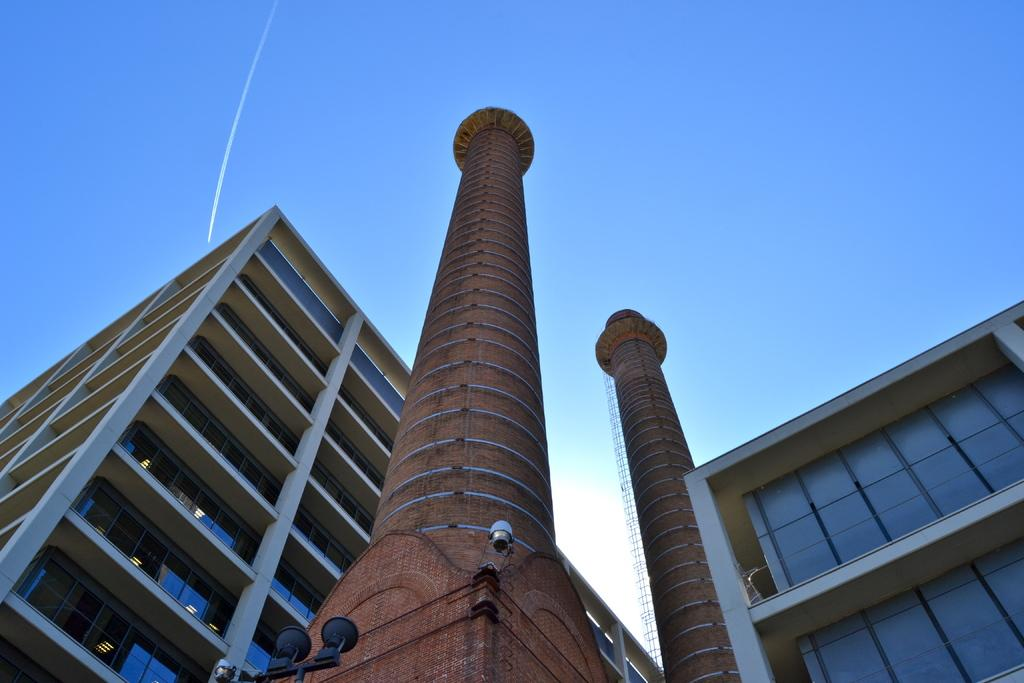How many pillars can be seen in the image? There are two pillars in the image. What else is present in the image besides the pillars? There are buildings in the image. What feature do the pillars have? The pillars have lights on them. What color are the items associated with the pillars? The items associated with the pillars are black. What can be seen in the background of the image? The sky is visible behind the buildings. What type of waste is being disposed of by the authority in the image? There is no waste or authority present in the image. Can you tell me how many kittens are sitting on the pillars in the image? There are no kittens present in the image; only the pillars, buildings, lights, and black items are visible. 